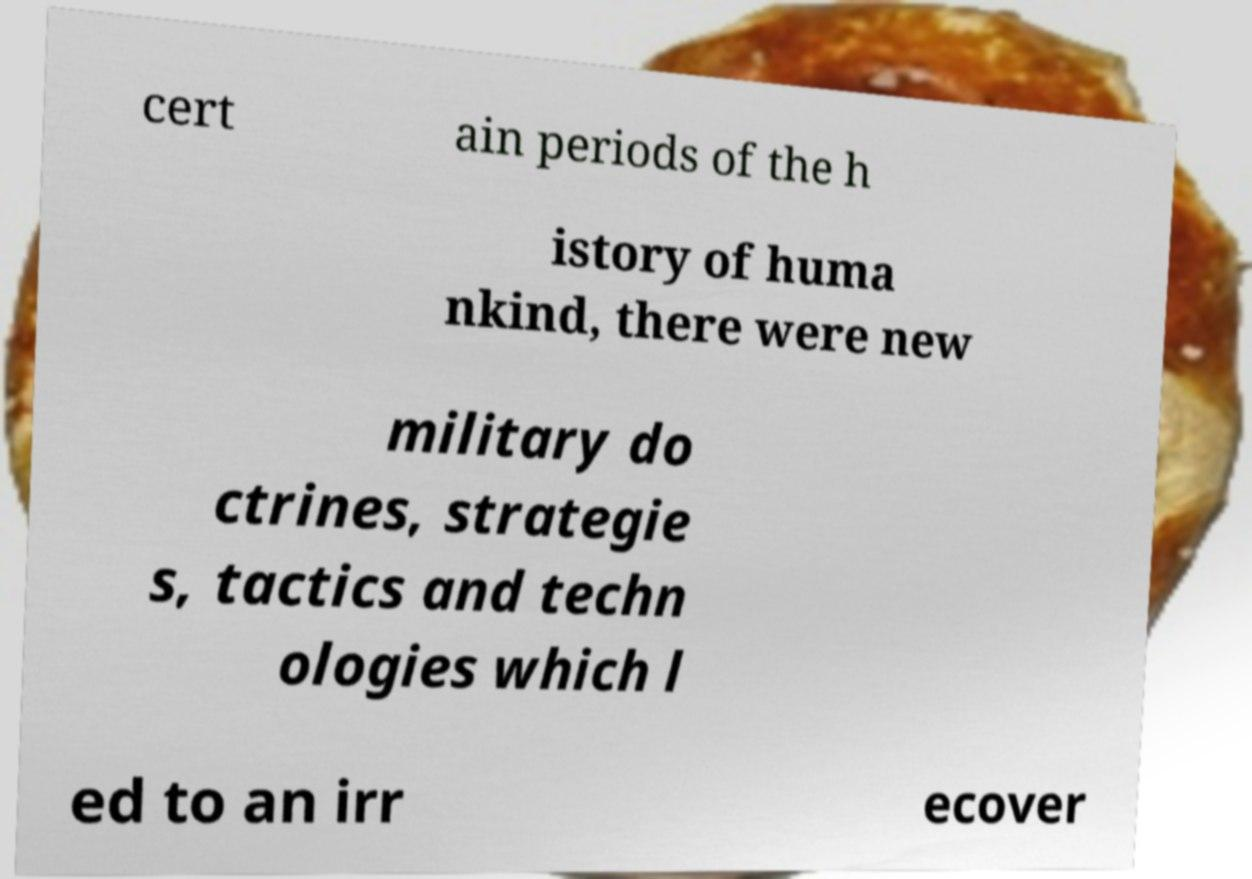Please identify and transcribe the text found in this image. cert ain periods of the h istory of huma nkind, there were new military do ctrines, strategie s, tactics and techn ologies which l ed to an irr ecover 